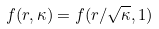Convert formula to latex. <formula><loc_0><loc_0><loc_500><loc_500>f ( r , \kappa ) = f ( r / \sqrt { \kappa } , 1 )</formula> 